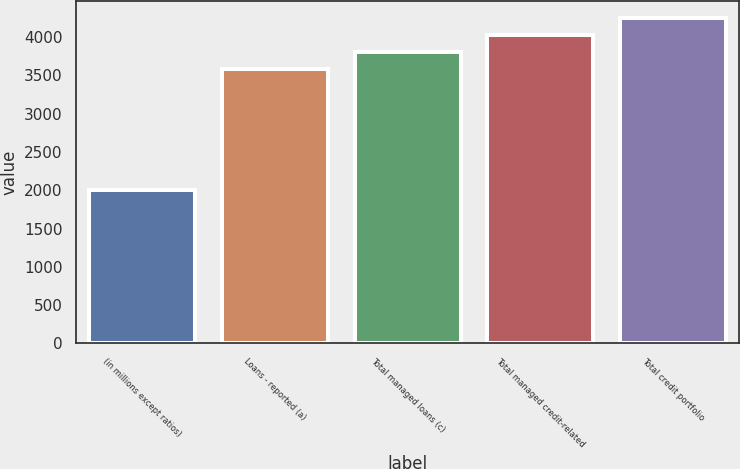<chart> <loc_0><loc_0><loc_500><loc_500><bar_chart><fcel>(in millions except ratios)<fcel>Loans - reported (a)<fcel>Total managed loans (c)<fcel>Total managed credit-related<fcel>Total credit portfolio<nl><fcel>2007<fcel>3586<fcel>3809<fcel>4032<fcel>4255<nl></chart> 